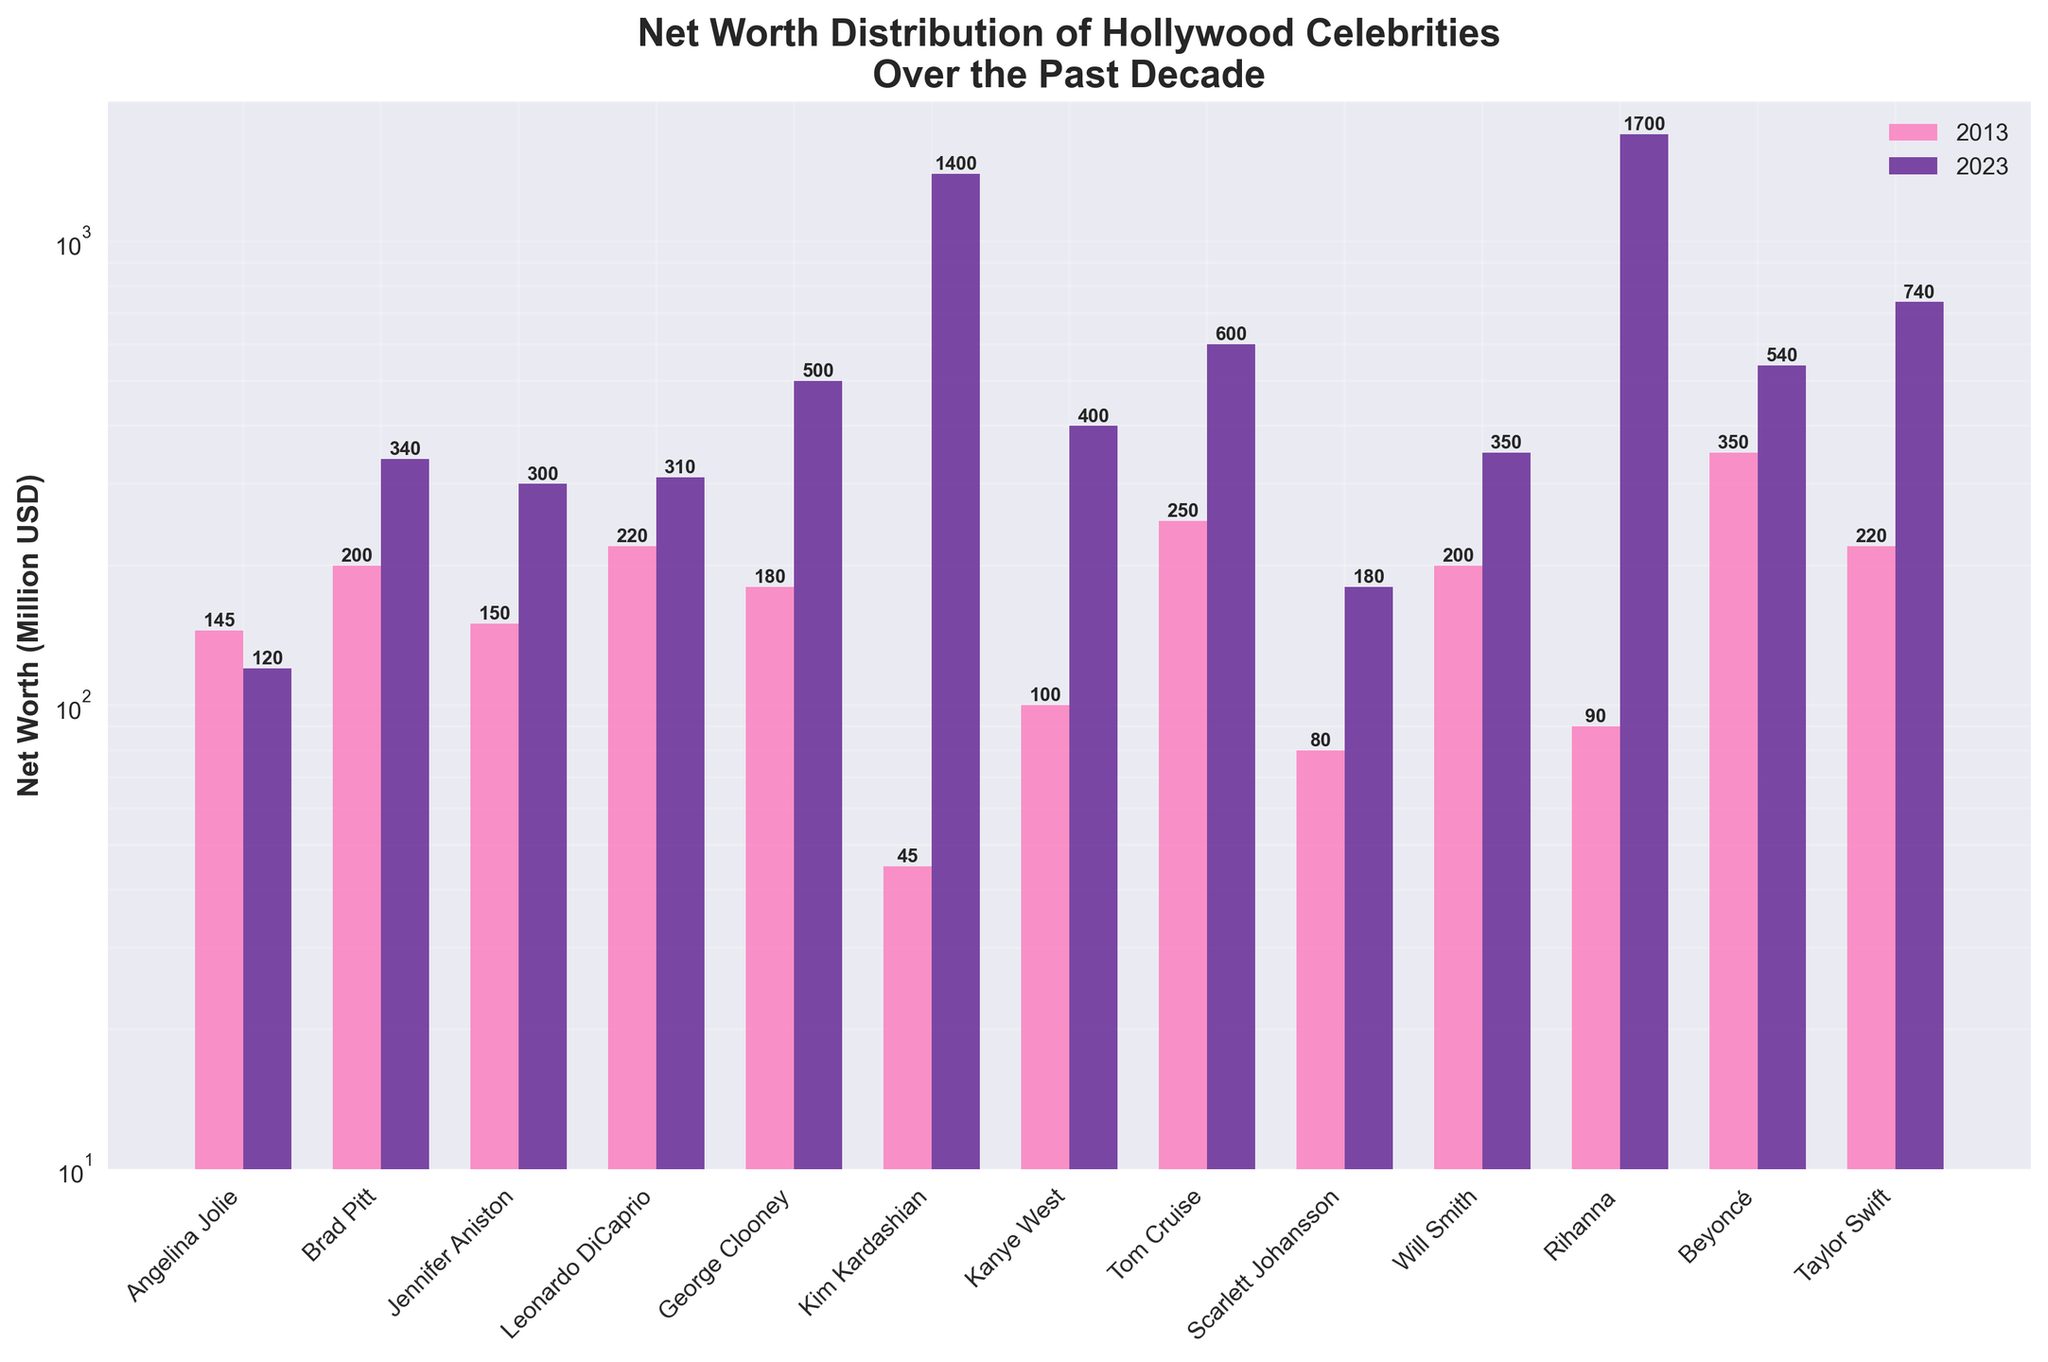What's the title of the plot? The title is displayed at the top of the plot, reading "Net Worth Distribution of Hollywood Celebrities Over the Past Decade".
Answer: Net Worth Distribution of Hollywood Celebrities Over the Past Decade What do the pink and purple bars represent? The legend indicates that the pink bars represent the net worths in 2013, and the purple bars represent the net worths in 2023.
Answer: 2013 and 2023 net worths Which celebrity had the highest net worth in 2013? On the y-axis with a log scale, which makes it easier to differentiate, Tom Cruise's bar in 2013 is the highest among all shown bars.
Answer: Tom Cruise How has Kim Kardashian's net worth changed over the decade? Comparing the pink and purple bars for Kim Kardashian, her net worth significantly increased from 45 million in 2013 to 1400 million in 2023.
Answer: Increased from 45 million to 1400 million Which celebrity has the largest difference in net worth between 2013 and 2023? By observing the plot, the difference between the bars for Rihanna in 2013 and 2023 is the largest, going from 90 million to 1700 million.
Answer: Rihanna What's the net worth of Beyoncé in 2023? The y-axis value for Beyoncé's purple bar in 2023 shows it reaches 540 million.
Answer: 540 million Which celebrities' net worth decreased over the past decade? By comparing the height of the bars for 2013 and 2023, only Angelina Jolie's bar is lower in 2023 compared to 2013.
Answer: Angelina Jolie What is the total net worth of Leonardo DiCaprio and Scarlett Johansson in 2023? Summing the net worth values from the plot, Leonardo DiCaprio (310 million) and Scarlett Johansson (180 million) make a total of 490 million.
Answer: 490 million Who had a larger net worth increase over the decade, Taylor Swift or Kanye West? Comparing the difference in bars, Taylor Swift increased from 220 million to 740 million (520 million increase), and Kanye West from 100 million to 400 million (300 million increase), so Taylor Swift had a larger increase.
Answer: Taylor Swift What does the y-axis scaling indicate about the net worth values? The y-axis is on a log scale, allowing for easier comparison of a wide range of values, indicating large differences in net worths among celebrities over the decade.
Answer: Log scale for wide range comparison 